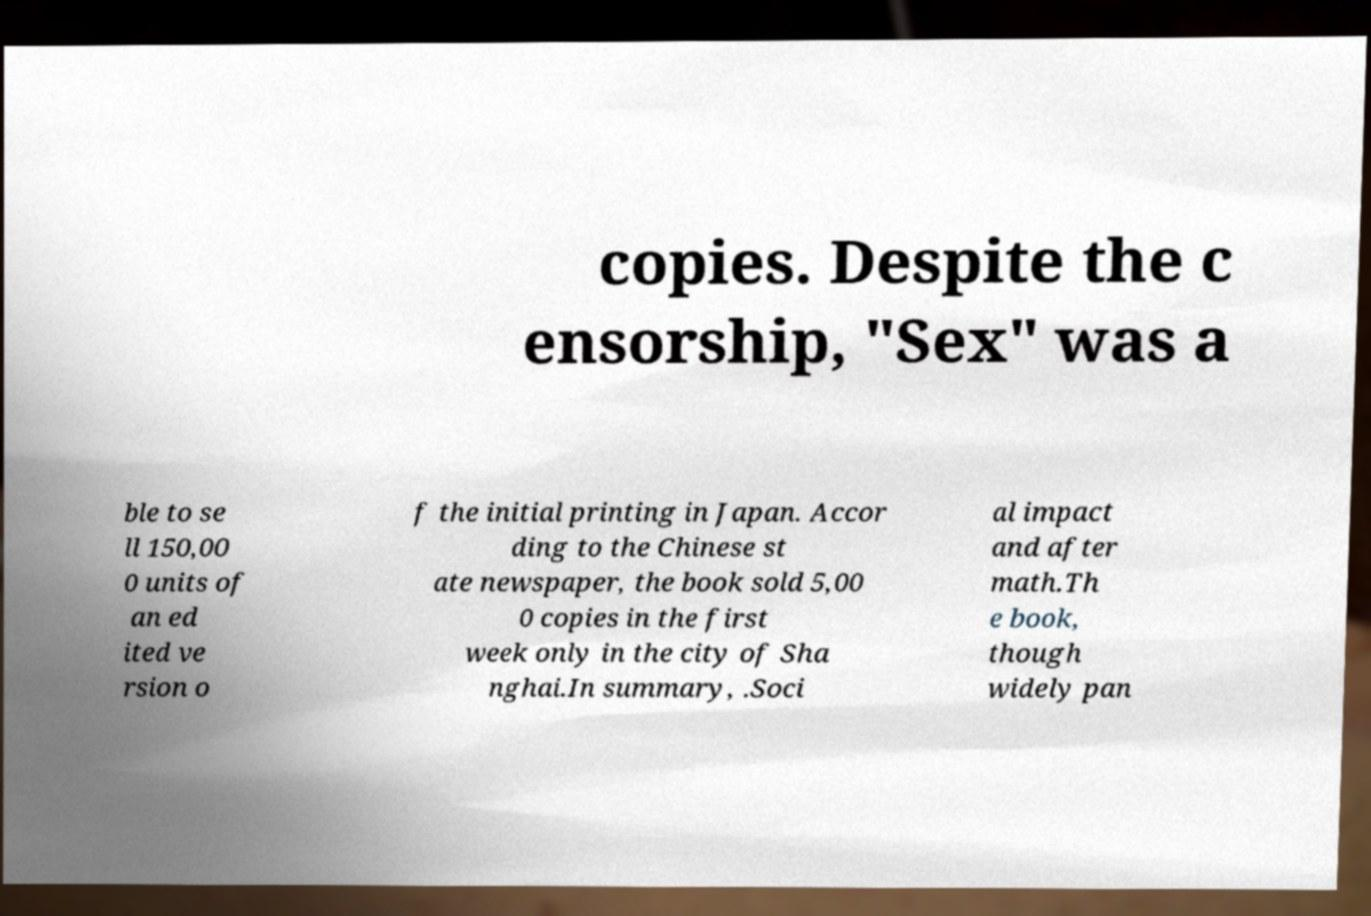Could you assist in decoding the text presented in this image and type it out clearly? copies. Despite the c ensorship, "Sex" was a ble to se ll 150,00 0 units of an ed ited ve rsion o f the initial printing in Japan. Accor ding to the Chinese st ate newspaper, the book sold 5,00 0 copies in the first week only in the city of Sha nghai.In summary, .Soci al impact and after math.Th e book, though widely pan 